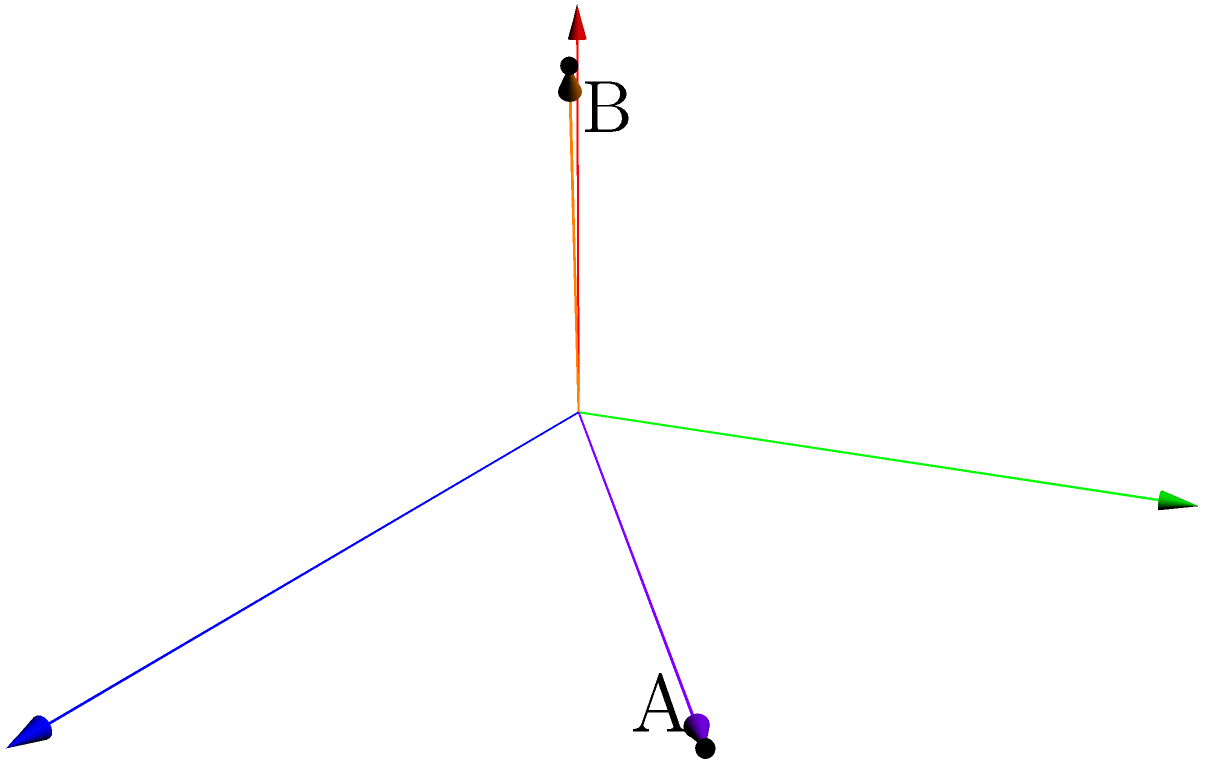In an isolation ward, two hospital beds are positioned as shown in the diagram. Bed A is represented by vector $\vec{a} = 3\hat{i} + 2\hat{j}$, and bed B is represented by vector $\vec{b} = 2\hat{i} + \hat{j} + 2\hat{k}$. Calculate the cross product $\vec{a} \times \vec{b}$ to determine the area of the parallelogram formed by these two vectors, which represents the spatial relationship between the beds. What is the magnitude of the resulting vector? To solve this problem, we'll follow these steps:

1) The cross product of two vectors $\vec{a} = (a_1, a_2, a_3)$ and $\vec{b} = (b_1, b_2, b_3)$ is given by:

   $\vec{a} \times \vec{b} = (a_2b_3 - a_3b_2)\hat{i} - (a_1b_3 - a_3b_1)\hat{j} + (a_1b_2 - a_2b_1)\hat{k}$

2) In our case:
   $\vec{a} = 3\hat{i} + 2\hat{j} + 0\hat{k} = (3, 2, 0)$
   $\vec{b} = 2\hat{i} + \hat{j} + 2\hat{k} = (2, 1, 2)$

3) Let's calculate each component:
   
   $i$ component: $(2)(2) - (0)(1) = 4$
   $j$ component: $-[(3)(2) - (0)(2)] = -6$
   $k$ component: $(3)(1) - (2)(2) = -1$

4) Therefore, $\vec{a} \times \vec{b} = 4\hat{i} - 6\hat{j} - \hat{k}$

5) The magnitude of this vector represents the area of the parallelogram formed by $\vec{a}$ and $\vec{b}$. We can calculate it using the Pythagorean theorem:

   $|\vec{a} \times \vec{b}| = \sqrt{4^2 + (-6)^2 + (-1)^2}$

6) Simplifying:
   $|\vec{a} \times \vec{b}| = \sqrt{16 + 36 + 1} = \sqrt{53}$

Therefore, the magnitude of the cross product, which represents the area of the parallelogram formed by the two bed vectors, is $\sqrt{53}$ square units.
Answer: $\sqrt{53}$ square units 